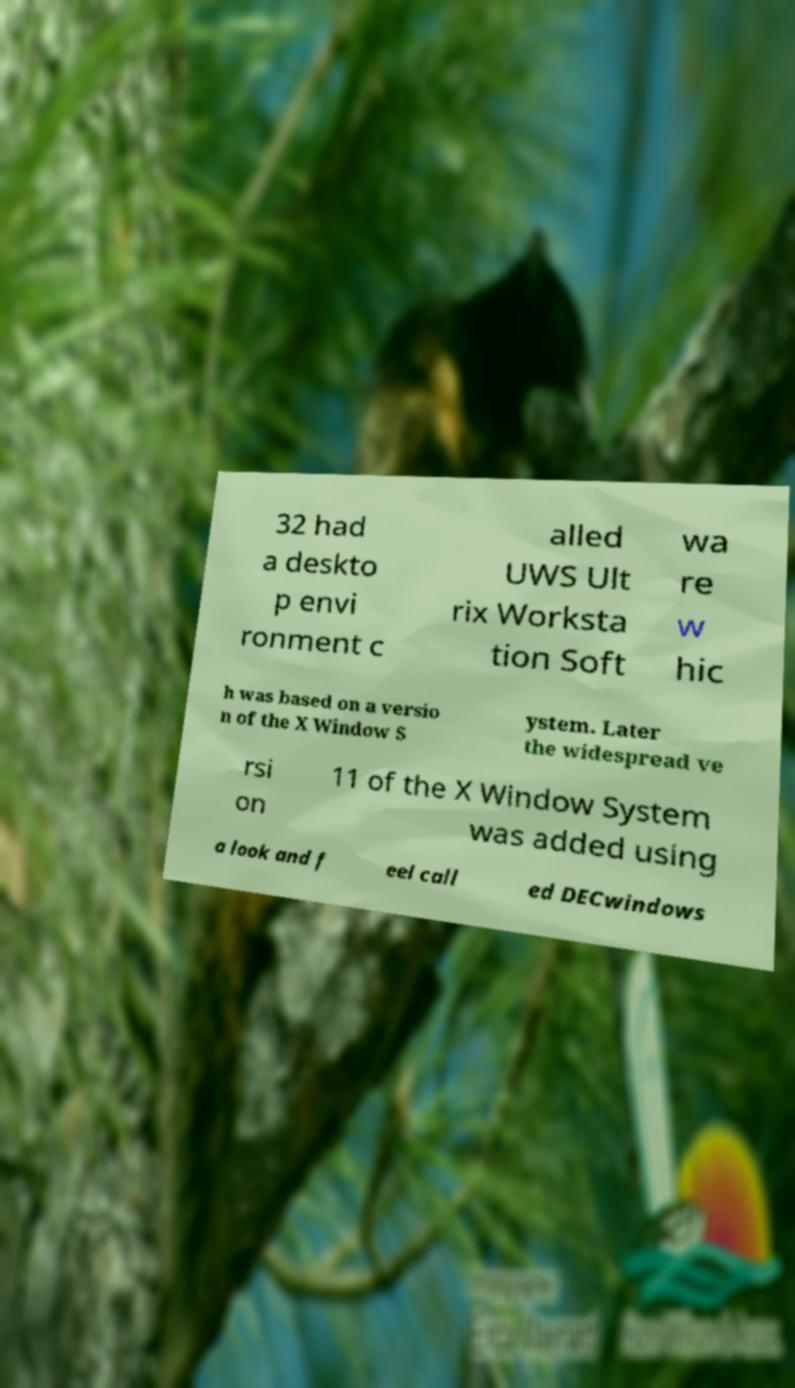There's text embedded in this image that I need extracted. Can you transcribe it verbatim? 32 had a deskto p envi ronment c alled UWS Ult rix Worksta tion Soft wa re w hic h was based on a versio n of the X Window S ystem. Later the widespread ve rsi on 11 of the X Window System was added using a look and f eel call ed DECwindows 